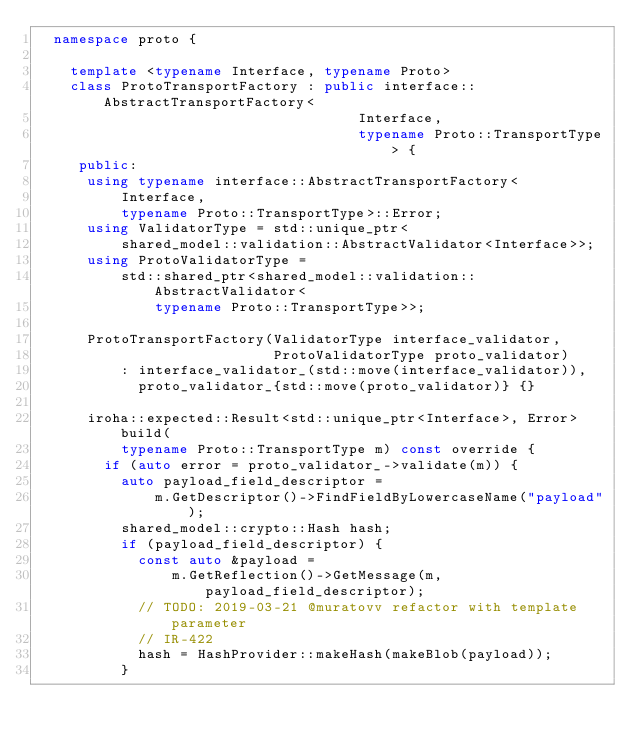Convert code to text. <code><loc_0><loc_0><loc_500><loc_500><_C++_>  namespace proto {

    template <typename Interface, typename Proto>
    class ProtoTransportFactory : public interface::AbstractTransportFactory<
                                      Interface,
                                      typename Proto::TransportType> {
     public:
      using typename interface::AbstractTransportFactory<
          Interface,
          typename Proto::TransportType>::Error;
      using ValidatorType = std::unique_ptr<
          shared_model::validation::AbstractValidator<Interface>>;
      using ProtoValidatorType =
          std::shared_ptr<shared_model::validation::AbstractValidator<
              typename Proto::TransportType>>;

      ProtoTransportFactory(ValidatorType interface_validator,
                            ProtoValidatorType proto_validator)
          : interface_validator_(std::move(interface_validator)),
            proto_validator_{std::move(proto_validator)} {}

      iroha::expected::Result<std::unique_ptr<Interface>, Error> build(
          typename Proto::TransportType m) const override {
        if (auto error = proto_validator_->validate(m)) {
          auto payload_field_descriptor =
              m.GetDescriptor()->FindFieldByLowercaseName("payload");
          shared_model::crypto::Hash hash;
          if (payload_field_descriptor) {
            const auto &payload =
                m.GetReflection()->GetMessage(m, payload_field_descriptor);
            // TODO: 2019-03-21 @muratovv refactor with template parameter
            // IR-422
            hash = HashProvider::makeHash(makeBlob(payload));
          }</code> 